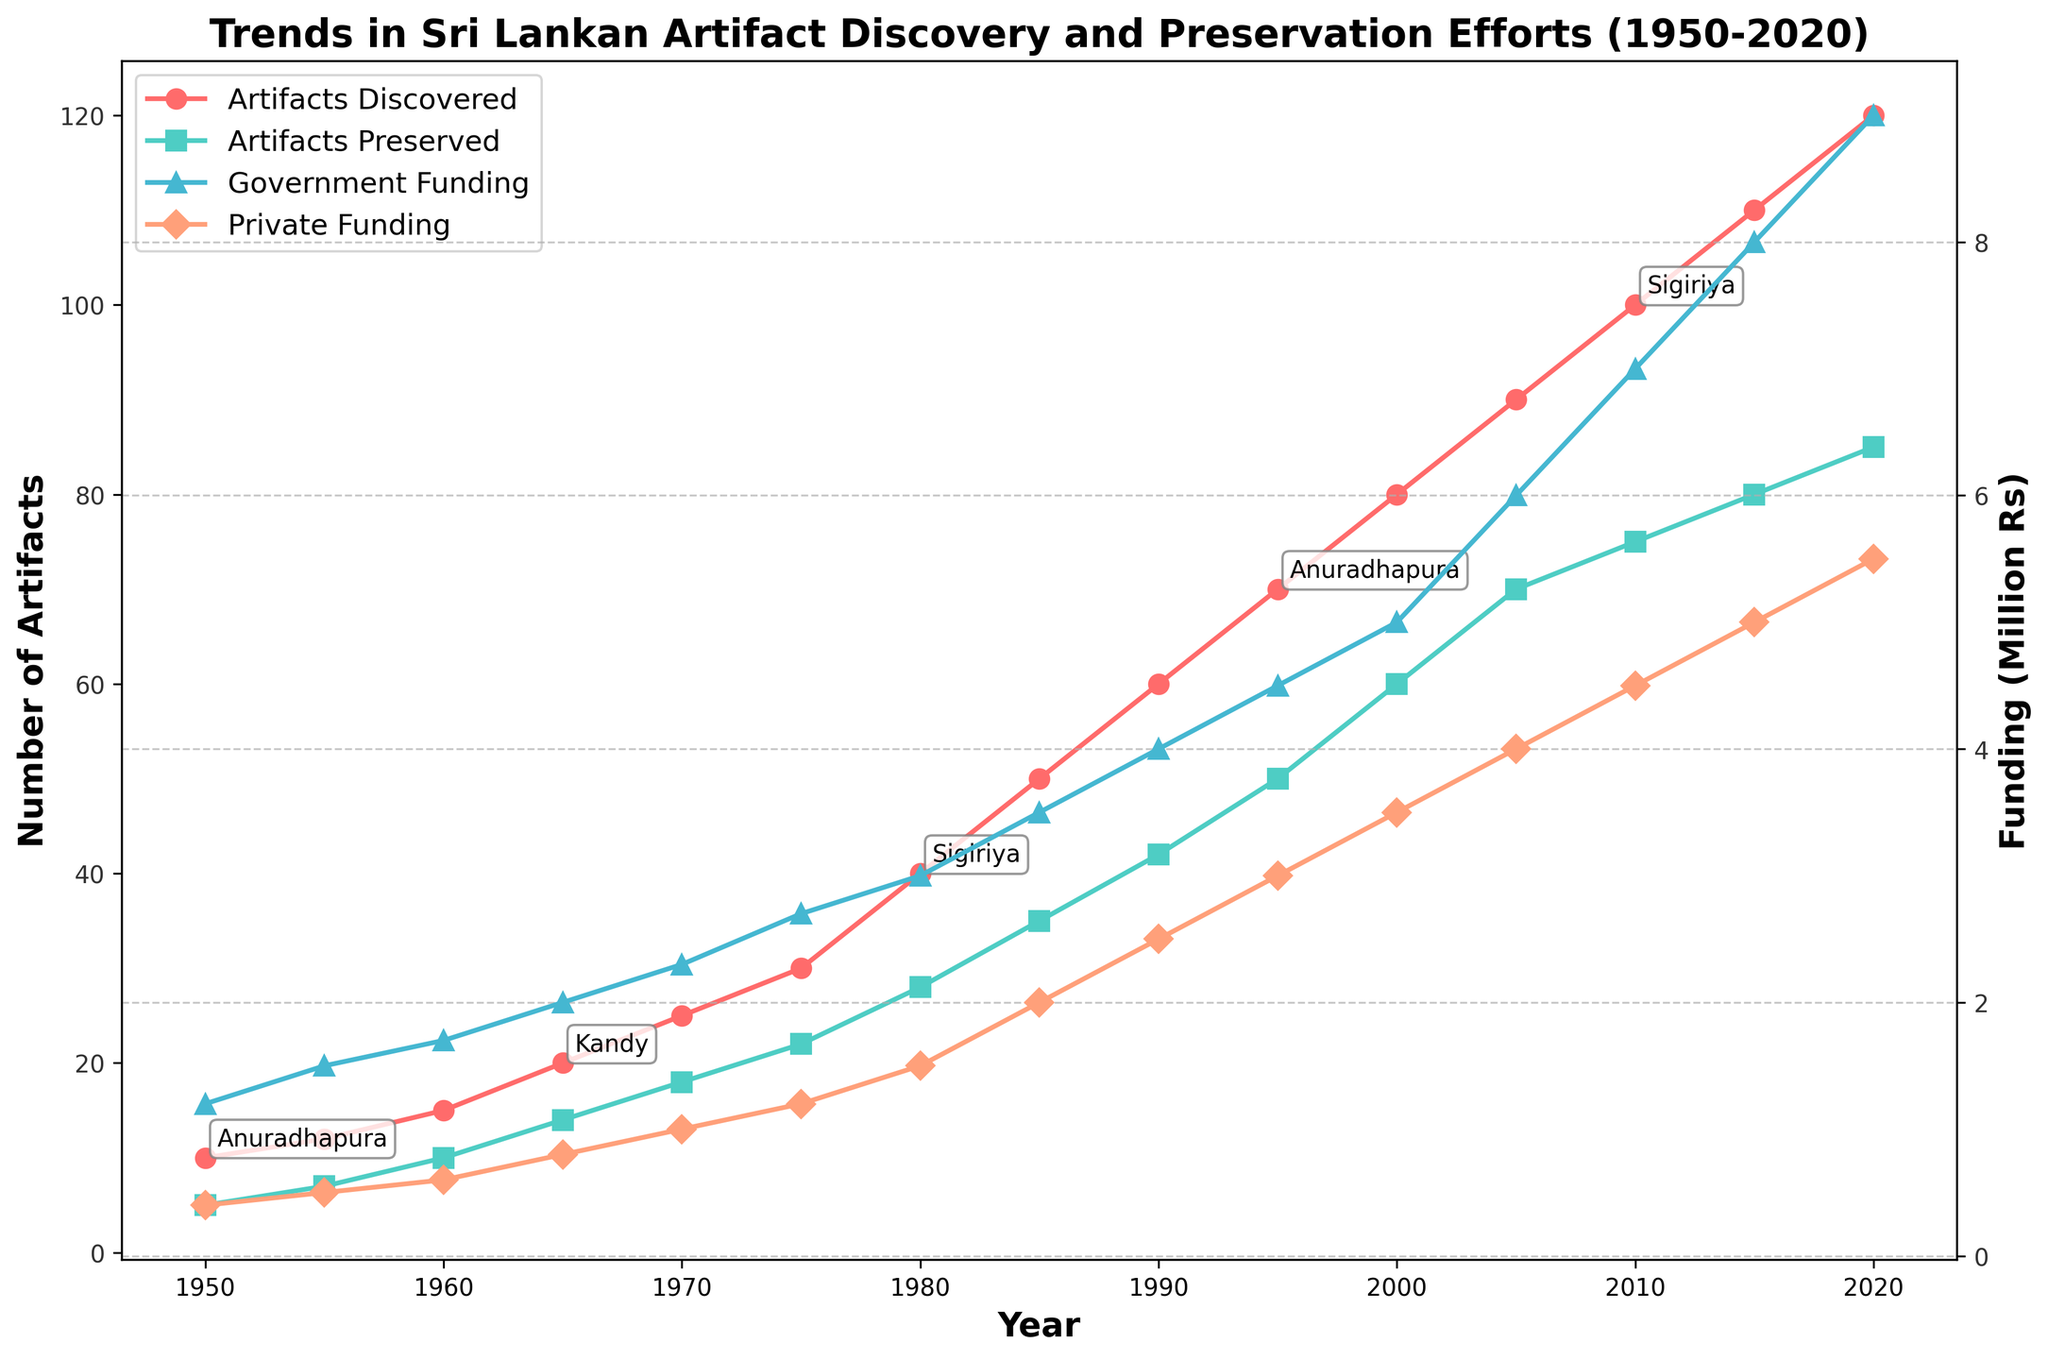How many distinct major dig sites are annotated in the figure? The plot's legend and annotations are visual indicators for identifying distinct major dig sites. By counting each unique site mentioned in the annotations or checking the text labels at the points on the lines, we find the total number of unique sites.
Answer: 7 What is the overall trend of government funding from 1950 to 2020? The line representing government funding is analyzed for its general direction over time. The visual inspection from the figure shows a continuous upward trend.
Answer: Increasing Between 1960 and 1965, how much did the number of artifacts preserved increase? By checking the 'Artifacts Preserved' values at the years 1960 and 1965, we find the numbers are 10 and 14, respectively. Subtracting these values gives the increase: 14 - 10.
Answer: 4 Which year had the same major dig site as 1970? Referring to the annotations or text labels for the year 1970 in the figure, the major dig site is Anuradhapura. Checking other years with the same site visually, we find that 1950, 1995, and 1970 share Anuradhapura as a major dig site.
Answer: 1950, 1995 Is there a year when artifacts discovered and private funding both showed a significant increase? Comparing the trends in both 'Artifacts Discovered' and 'Private Funding,' we see a notable simultaneous rise around the year 2005. The data shows artifacts discovered sharply increased from 80 to 90, and private funding rose from 3.5 to 4.0 million Rs.
Answer: 2005 Which funding source generally showed a higher amount, government or private funding? Examining the two lines for government and private funding, it is apparent that the line for government funding is consistently higher throughout the timeframe.
Answer: Government funding What was the rate of increase in the number of artifacts discovered from 1980 to 1990? Between 1980 and 1990, the number of artifacts discovered increased from 40 to 60. To find the rate, calculate the difference and divide by the number of years: (60 - 40) / (1990 - 1980) = 20 / 10.
Answer: 2 artifacts per year During which decade did the number of artifacts preserved surpass 50? Observing the 'Artifacts Preserved' line, it surpasses 50 between 1990 and 1995. Checking specific years confirms that in 1995, the number of artifacts preserved was 50.
Answer: 1990s What's the difference between government and private funding in 2010? The 'Government Funding' in 2010 is 7.0 million Rs, and 'Private Funding' is 4.5 million Rs. Subtract these values to find the difference: 7.0 - 4.5.
Answer: 2.5 million Rs How frequently are dig sites annotated on the plot? From the explanation in the code comments, annotations are added for every third point. Counting them visually confirms they appear roughly every third year.
Answer: Every third year 